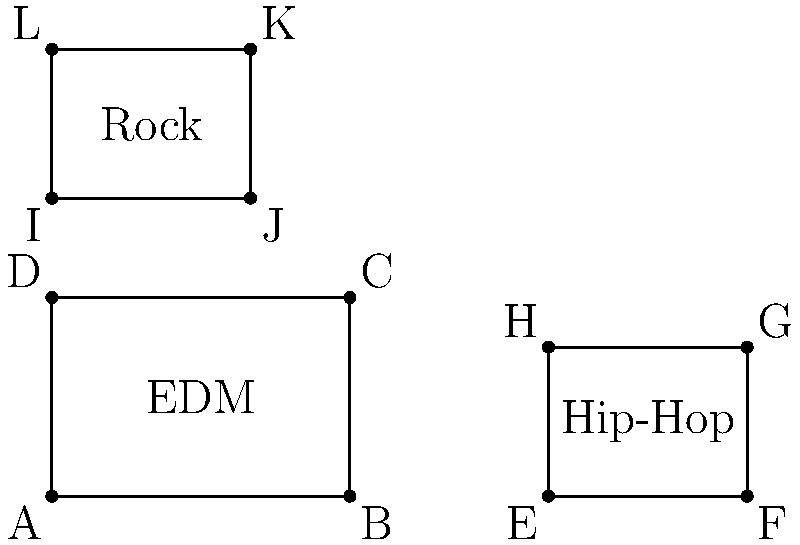As a DJ, you're organizing your playlist using congruent polygons to represent different music genres. The rectangles in the diagram represent EDM, Hip-Hop, and Rock tracks. If the area of the EDM rectangle (ABCD) is 6 square units, what is the total area of all three rectangles combined? Let's approach this step-by-step:

1) We're given that the area of the EDM rectangle (ABCD) is 6 square units.

2) We can see that all three rectangles are congruent, meaning they have the same shape and size.

3) Since they're congruent, each rectangle has the same area.

4) If one rectangle has an area of 6 square units, then:
   EDM area = 6 sq units
   Hip-Hop area = 6 sq units
   Rock area = 6 sq units

5) To find the total area, we sum the areas of all three rectangles:
   Total area = EDM area + Hip-Hop area + Rock area
               = 6 + 6 + 6
               = 18 square units

Therefore, the total area of all three rectangles combined is 18 square units.
Answer: 18 square units 